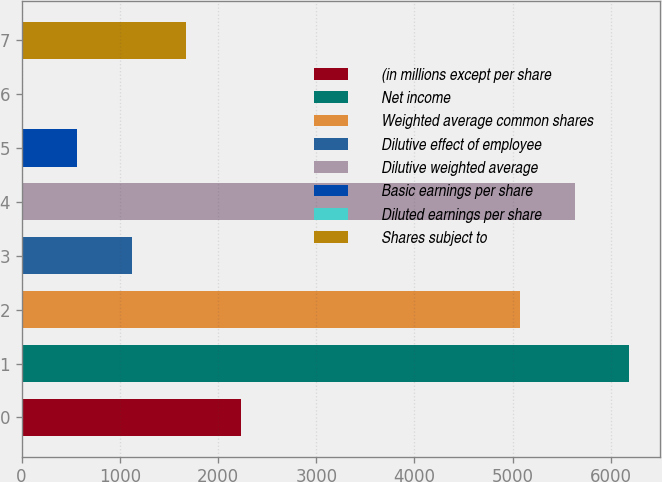Convert chart to OTSL. <chart><loc_0><loc_0><loc_500><loc_500><bar_chart><fcel>(in millions except per share<fcel>Net income<fcel>Weighted average common shares<fcel>Dilutive effect of employee<fcel>Dilutive weighted average<fcel>Basic earnings per share<fcel>Diluted earnings per share<fcel>Shares subject to<nl><fcel>2237.85<fcel>6188.38<fcel>5070<fcel>1119.47<fcel>5629.19<fcel>560.28<fcel>1.09<fcel>1678.66<nl></chart> 